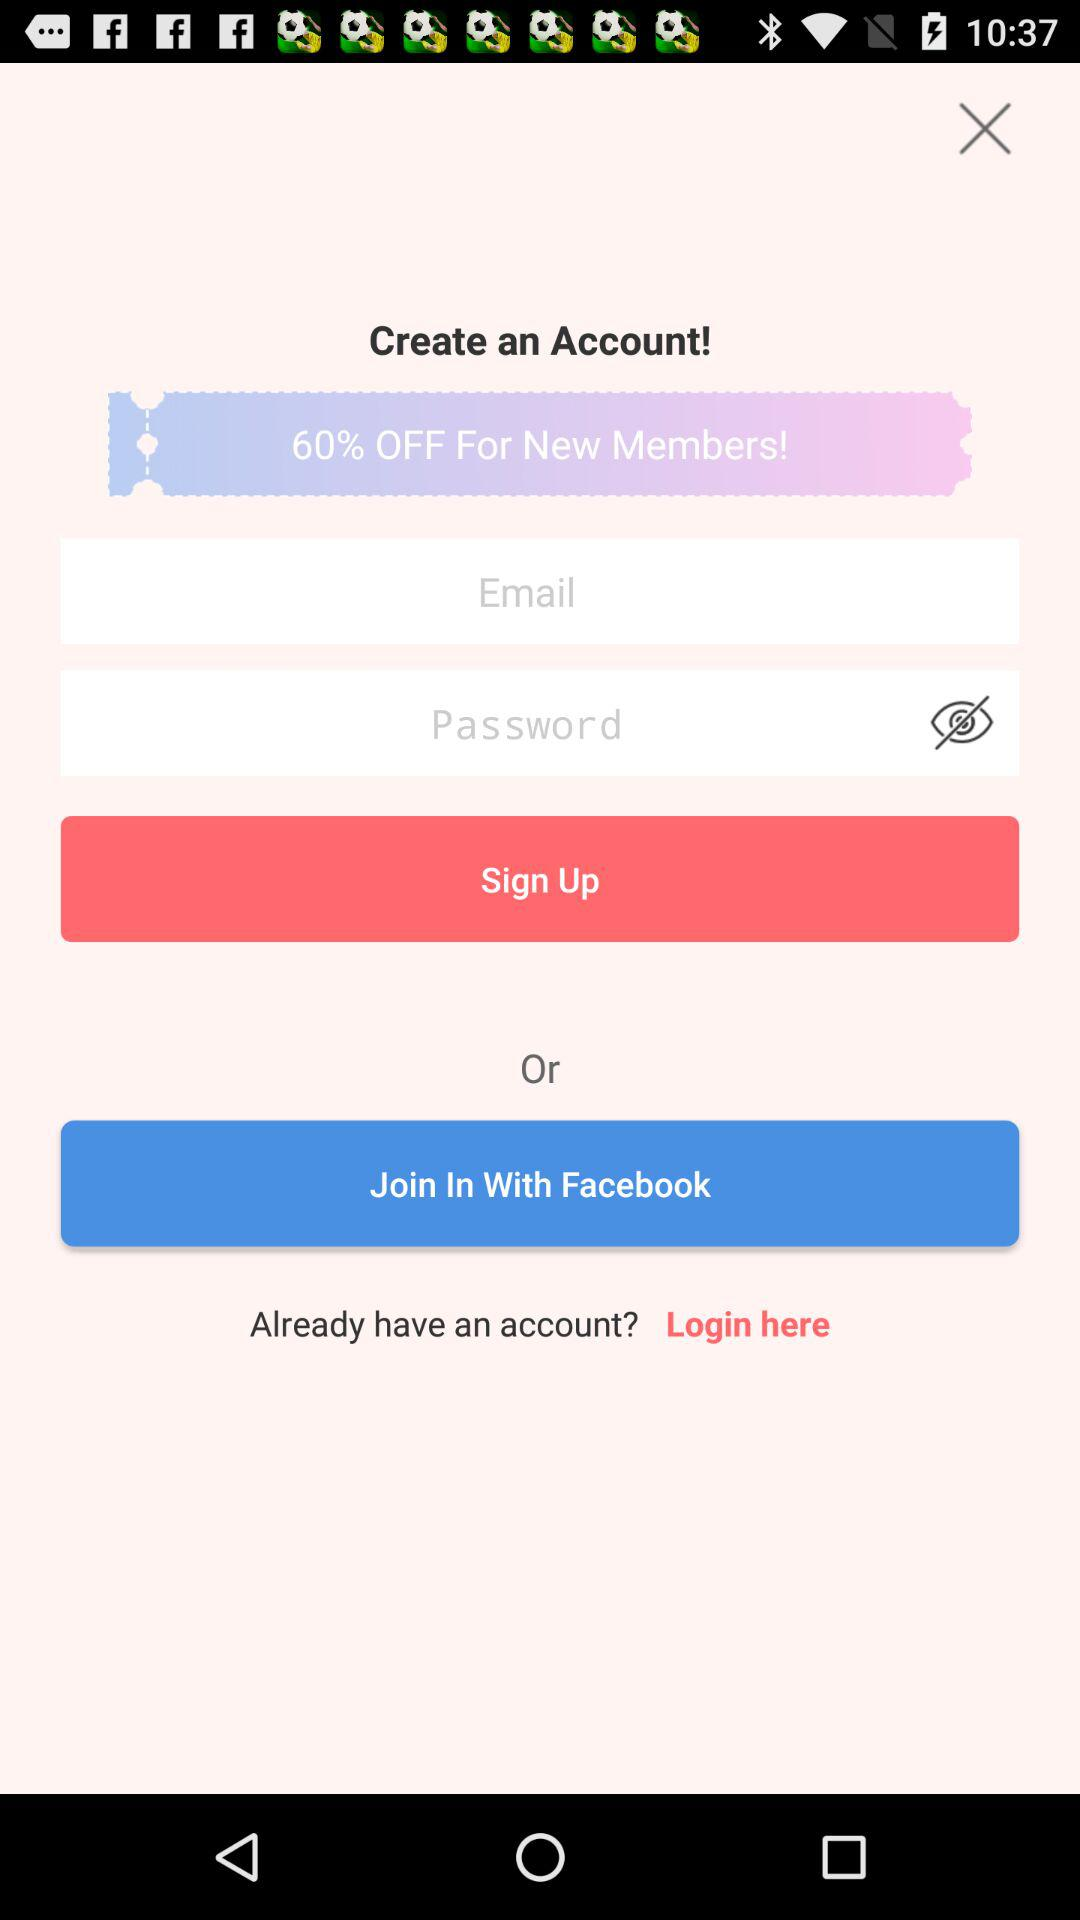How many login options are there on this screen?
Answer the question using a single word or phrase. 2 